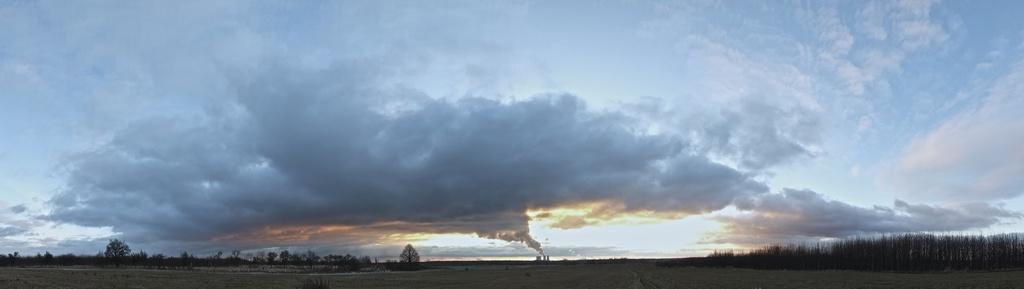Please provide a concise description of this image. As we can see in the image, there is sky, clouds and in the background there is grass, ground and trees. 